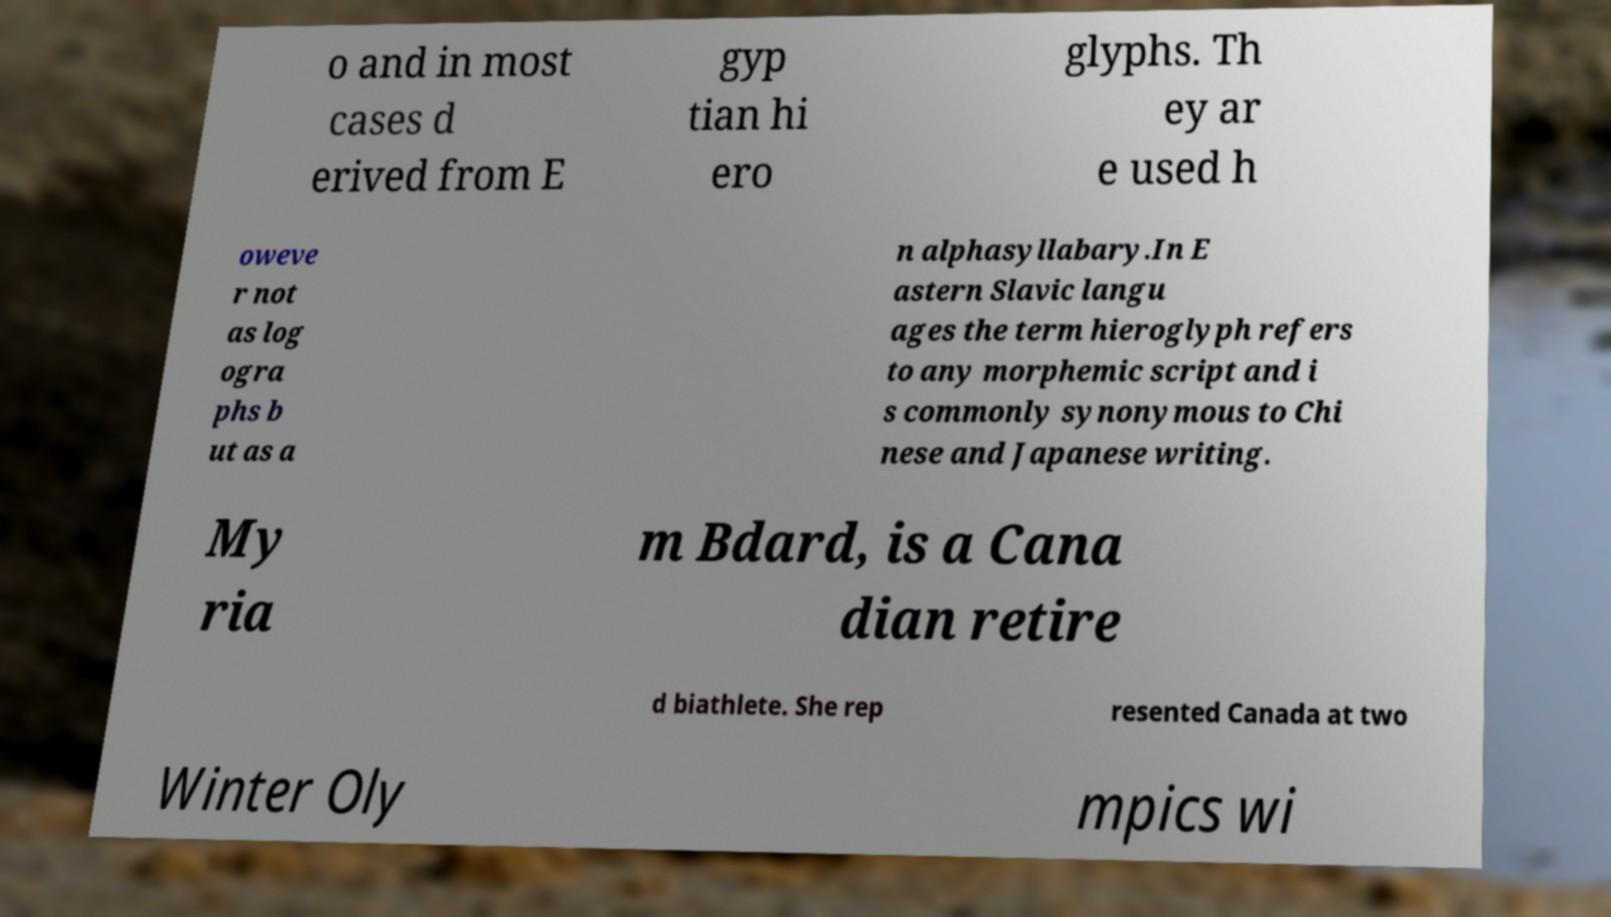There's text embedded in this image that I need extracted. Can you transcribe it verbatim? o and in most cases d erived from E gyp tian hi ero glyphs. Th ey ar e used h oweve r not as log ogra phs b ut as a n alphasyllabary.In E astern Slavic langu ages the term hieroglyph refers to any morphemic script and i s commonly synonymous to Chi nese and Japanese writing. My ria m Bdard, is a Cana dian retire d biathlete. She rep resented Canada at two Winter Oly mpics wi 